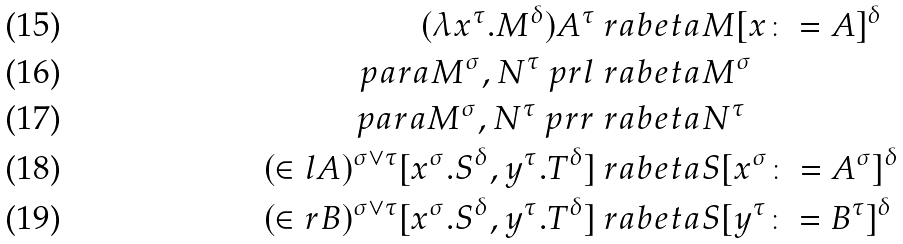Convert formula to latex. <formula><loc_0><loc_0><loc_500><loc_500>( \lambda x ^ { \tau } . M ^ { \delta } ) A ^ { \tau } & \ r a b e t a M [ x \colon = A ] ^ { \delta } \\ \ p a r a { M ^ { \sigma } , N ^ { \tau } } \ p r l & \ r a b e t a M ^ { \sigma } \\ \ p a r a { M ^ { \sigma } , N ^ { \tau } } \ p r r & \ r a b e t a N ^ { \tau } \\ ( \in l A ) ^ { \sigma \vee \tau } [ x ^ { \sigma } . S ^ { \delta } , y ^ { \tau } . T ^ { \delta } ] & \ r a b e t a S [ x ^ { \sigma } \colon = A ^ { \sigma } ] ^ { \delta } \\ ( \in r B ) ^ { \sigma \vee \tau } [ x ^ { \sigma } . S ^ { \delta } , y ^ { \tau } . T ^ { \delta } ] & \ r a b e t a S [ y ^ { \tau } \colon = B ^ { \tau } ] ^ { \delta }</formula> 